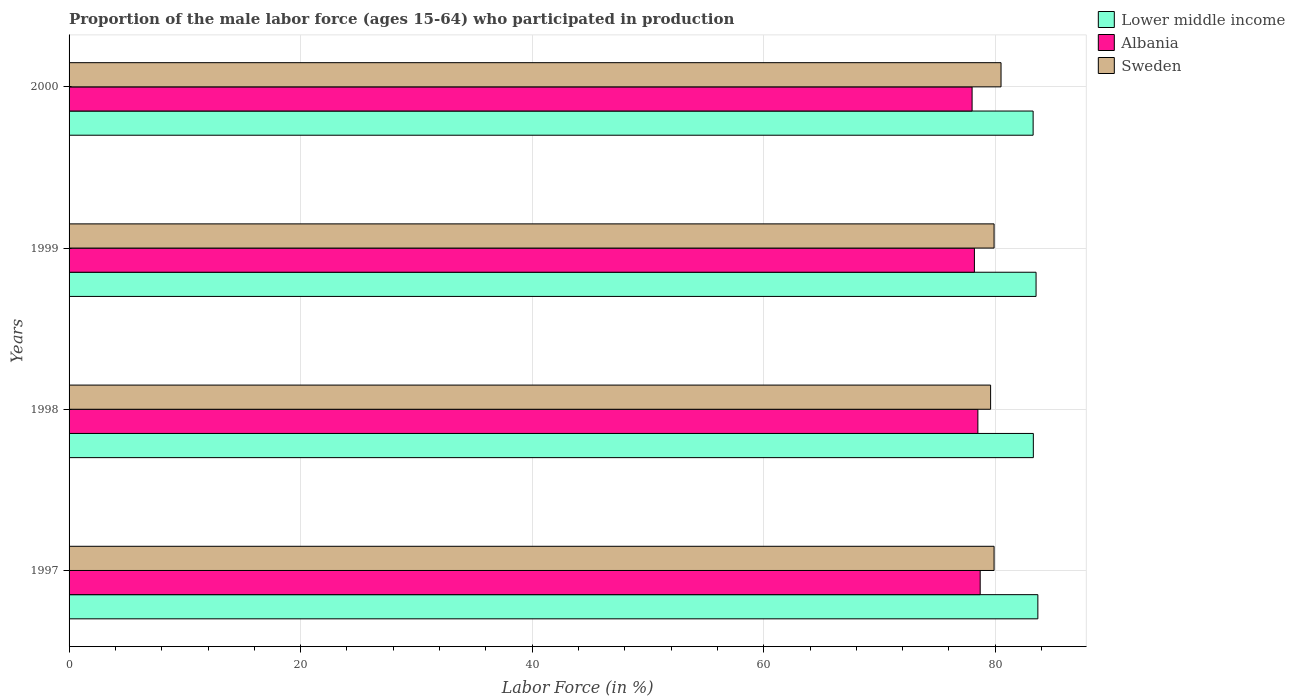Are the number of bars on each tick of the Y-axis equal?
Keep it short and to the point. Yes. How many bars are there on the 2nd tick from the bottom?
Provide a short and direct response. 3. What is the proportion of the male labor force who participated in production in Sweden in 1999?
Keep it short and to the point. 79.9. Across all years, what is the maximum proportion of the male labor force who participated in production in Sweden?
Your response must be concise. 80.5. Across all years, what is the minimum proportion of the male labor force who participated in production in Sweden?
Your response must be concise. 79.6. In which year was the proportion of the male labor force who participated in production in Albania maximum?
Offer a very short reply. 1997. In which year was the proportion of the male labor force who participated in production in Lower middle income minimum?
Offer a terse response. 2000. What is the total proportion of the male labor force who participated in production in Albania in the graph?
Make the answer very short. 313.4. What is the difference between the proportion of the male labor force who participated in production in Lower middle income in 1997 and that in 1998?
Give a very brief answer. 0.39. What is the difference between the proportion of the male labor force who participated in production in Albania in 2000 and the proportion of the male labor force who participated in production in Lower middle income in 1998?
Provide a short and direct response. -5.29. What is the average proportion of the male labor force who participated in production in Sweden per year?
Keep it short and to the point. 79.98. In how many years, is the proportion of the male labor force who participated in production in Lower middle income greater than 4 %?
Your answer should be very brief. 4. What is the ratio of the proportion of the male labor force who participated in production in Sweden in 1999 to that in 2000?
Your response must be concise. 0.99. Is the proportion of the male labor force who participated in production in Albania in 1998 less than that in 1999?
Your answer should be very brief. No. What is the difference between the highest and the second highest proportion of the male labor force who participated in production in Sweden?
Make the answer very short. 0.6. What is the difference between the highest and the lowest proportion of the male labor force who participated in production in Albania?
Your response must be concise. 0.7. In how many years, is the proportion of the male labor force who participated in production in Albania greater than the average proportion of the male labor force who participated in production in Albania taken over all years?
Ensure brevity in your answer.  2. How many bars are there?
Your answer should be compact. 12. Are all the bars in the graph horizontal?
Provide a short and direct response. Yes. What is the difference between two consecutive major ticks on the X-axis?
Provide a short and direct response. 20. Are the values on the major ticks of X-axis written in scientific E-notation?
Provide a short and direct response. No. Does the graph contain grids?
Make the answer very short. Yes. How many legend labels are there?
Your answer should be compact. 3. How are the legend labels stacked?
Your answer should be compact. Vertical. What is the title of the graph?
Offer a terse response. Proportion of the male labor force (ages 15-64) who participated in production. Does "Macedonia" appear as one of the legend labels in the graph?
Make the answer very short. No. What is the label or title of the X-axis?
Your answer should be compact. Labor Force (in %). What is the Labor Force (in %) of Lower middle income in 1997?
Offer a terse response. 83.68. What is the Labor Force (in %) of Albania in 1997?
Offer a very short reply. 78.7. What is the Labor Force (in %) in Sweden in 1997?
Give a very brief answer. 79.9. What is the Labor Force (in %) in Lower middle income in 1998?
Provide a short and direct response. 83.29. What is the Labor Force (in %) in Albania in 1998?
Give a very brief answer. 78.5. What is the Labor Force (in %) in Sweden in 1998?
Provide a short and direct response. 79.6. What is the Labor Force (in %) in Lower middle income in 1999?
Your response must be concise. 83.53. What is the Labor Force (in %) of Albania in 1999?
Offer a very short reply. 78.2. What is the Labor Force (in %) in Sweden in 1999?
Your answer should be compact. 79.9. What is the Labor Force (in %) of Lower middle income in 2000?
Ensure brevity in your answer.  83.27. What is the Labor Force (in %) of Albania in 2000?
Ensure brevity in your answer.  78. What is the Labor Force (in %) of Sweden in 2000?
Keep it short and to the point. 80.5. Across all years, what is the maximum Labor Force (in %) of Lower middle income?
Make the answer very short. 83.68. Across all years, what is the maximum Labor Force (in %) of Albania?
Provide a succinct answer. 78.7. Across all years, what is the maximum Labor Force (in %) of Sweden?
Make the answer very short. 80.5. Across all years, what is the minimum Labor Force (in %) of Lower middle income?
Provide a short and direct response. 83.27. Across all years, what is the minimum Labor Force (in %) of Albania?
Offer a very short reply. 78. Across all years, what is the minimum Labor Force (in %) in Sweden?
Ensure brevity in your answer.  79.6. What is the total Labor Force (in %) of Lower middle income in the graph?
Your response must be concise. 333.77. What is the total Labor Force (in %) of Albania in the graph?
Keep it short and to the point. 313.4. What is the total Labor Force (in %) of Sweden in the graph?
Offer a terse response. 319.9. What is the difference between the Labor Force (in %) in Lower middle income in 1997 and that in 1998?
Make the answer very short. 0.39. What is the difference between the Labor Force (in %) in Sweden in 1997 and that in 1998?
Give a very brief answer. 0.3. What is the difference between the Labor Force (in %) in Lower middle income in 1997 and that in 1999?
Make the answer very short. 0.16. What is the difference between the Labor Force (in %) in Lower middle income in 1997 and that in 2000?
Provide a short and direct response. 0.41. What is the difference between the Labor Force (in %) of Sweden in 1997 and that in 2000?
Your answer should be compact. -0.6. What is the difference between the Labor Force (in %) in Lower middle income in 1998 and that in 1999?
Give a very brief answer. -0.23. What is the difference between the Labor Force (in %) of Albania in 1998 and that in 1999?
Your response must be concise. 0.3. What is the difference between the Labor Force (in %) in Lower middle income in 1998 and that in 2000?
Your answer should be compact. 0.02. What is the difference between the Labor Force (in %) in Sweden in 1998 and that in 2000?
Your response must be concise. -0.9. What is the difference between the Labor Force (in %) in Lower middle income in 1999 and that in 2000?
Give a very brief answer. 0.25. What is the difference between the Labor Force (in %) of Albania in 1999 and that in 2000?
Provide a succinct answer. 0.2. What is the difference between the Labor Force (in %) of Sweden in 1999 and that in 2000?
Offer a very short reply. -0.6. What is the difference between the Labor Force (in %) of Lower middle income in 1997 and the Labor Force (in %) of Albania in 1998?
Keep it short and to the point. 5.18. What is the difference between the Labor Force (in %) in Lower middle income in 1997 and the Labor Force (in %) in Sweden in 1998?
Offer a very short reply. 4.08. What is the difference between the Labor Force (in %) of Lower middle income in 1997 and the Labor Force (in %) of Albania in 1999?
Offer a terse response. 5.48. What is the difference between the Labor Force (in %) of Lower middle income in 1997 and the Labor Force (in %) of Sweden in 1999?
Your answer should be compact. 3.78. What is the difference between the Labor Force (in %) in Lower middle income in 1997 and the Labor Force (in %) in Albania in 2000?
Provide a succinct answer. 5.68. What is the difference between the Labor Force (in %) of Lower middle income in 1997 and the Labor Force (in %) of Sweden in 2000?
Your answer should be very brief. 3.18. What is the difference between the Labor Force (in %) in Albania in 1997 and the Labor Force (in %) in Sweden in 2000?
Give a very brief answer. -1.8. What is the difference between the Labor Force (in %) of Lower middle income in 1998 and the Labor Force (in %) of Albania in 1999?
Give a very brief answer. 5.09. What is the difference between the Labor Force (in %) of Lower middle income in 1998 and the Labor Force (in %) of Sweden in 1999?
Provide a succinct answer. 3.39. What is the difference between the Labor Force (in %) of Albania in 1998 and the Labor Force (in %) of Sweden in 1999?
Provide a succinct answer. -1.4. What is the difference between the Labor Force (in %) of Lower middle income in 1998 and the Labor Force (in %) of Albania in 2000?
Provide a short and direct response. 5.29. What is the difference between the Labor Force (in %) of Lower middle income in 1998 and the Labor Force (in %) of Sweden in 2000?
Provide a succinct answer. 2.79. What is the difference between the Labor Force (in %) in Albania in 1998 and the Labor Force (in %) in Sweden in 2000?
Your answer should be compact. -2. What is the difference between the Labor Force (in %) in Lower middle income in 1999 and the Labor Force (in %) in Albania in 2000?
Your response must be concise. 5.53. What is the difference between the Labor Force (in %) of Lower middle income in 1999 and the Labor Force (in %) of Sweden in 2000?
Provide a short and direct response. 3.03. What is the average Labor Force (in %) in Lower middle income per year?
Make the answer very short. 83.44. What is the average Labor Force (in %) in Albania per year?
Provide a short and direct response. 78.35. What is the average Labor Force (in %) of Sweden per year?
Keep it short and to the point. 79.97. In the year 1997, what is the difference between the Labor Force (in %) of Lower middle income and Labor Force (in %) of Albania?
Your response must be concise. 4.98. In the year 1997, what is the difference between the Labor Force (in %) in Lower middle income and Labor Force (in %) in Sweden?
Your response must be concise. 3.78. In the year 1998, what is the difference between the Labor Force (in %) in Lower middle income and Labor Force (in %) in Albania?
Offer a very short reply. 4.79. In the year 1998, what is the difference between the Labor Force (in %) of Lower middle income and Labor Force (in %) of Sweden?
Offer a very short reply. 3.69. In the year 1999, what is the difference between the Labor Force (in %) in Lower middle income and Labor Force (in %) in Albania?
Give a very brief answer. 5.33. In the year 1999, what is the difference between the Labor Force (in %) of Lower middle income and Labor Force (in %) of Sweden?
Your answer should be very brief. 3.63. In the year 1999, what is the difference between the Labor Force (in %) in Albania and Labor Force (in %) in Sweden?
Provide a succinct answer. -1.7. In the year 2000, what is the difference between the Labor Force (in %) in Lower middle income and Labor Force (in %) in Albania?
Give a very brief answer. 5.27. In the year 2000, what is the difference between the Labor Force (in %) in Lower middle income and Labor Force (in %) in Sweden?
Ensure brevity in your answer.  2.77. What is the ratio of the Labor Force (in %) in Lower middle income in 1997 to that in 1998?
Provide a short and direct response. 1. What is the ratio of the Labor Force (in %) in Sweden in 1997 to that in 1998?
Your answer should be compact. 1. What is the ratio of the Labor Force (in %) of Lower middle income in 1997 to that in 1999?
Ensure brevity in your answer.  1. What is the ratio of the Labor Force (in %) of Albania in 1997 to that in 1999?
Your answer should be compact. 1.01. What is the ratio of the Labor Force (in %) of Lower middle income in 1997 to that in 2000?
Your answer should be compact. 1. What is the ratio of the Labor Force (in %) of Albania in 1997 to that in 2000?
Provide a short and direct response. 1.01. What is the ratio of the Labor Force (in %) in Sweden in 1997 to that in 2000?
Your response must be concise. 0.99. What is the ratio of the Labor Force (in %) of Lower middle income in 1998 to that in 1999?
Offer a terse response. 1. What is the ratio of the Labor Force (in %) in Sweden in 1998 to that in 1999?
Provide a succinct answer. 1. What is the ratio of the Labor Force (in %) of Albania in 1998 to that in 2000?
Your response must be concise. 1.01. What is the ratio of the Labor Force (in %) of Sweden in 1998 to that in 2000?
Keep it short and to the point. 0.99. What is the ratio of the Labor Force (in %) of Lower middle income in 1999 to that in 2000?
Ensure brevity in your answer.  1. What is the difference between the highest and the second highest Labor Force (in %) in Lower middle income?
Your answer should be very brief. 0.16. What is the difference between the highest and the second highest Labor Force (in %) in Albania?
Ensure brevity in your answer.  0.2. What is the difference between the highest and the lowest Labor Force (in %) of Lower middle income?
Offer a terse response. 0.41. What is the difference between the highest and the lowest Labor Force (in %) in Albania?
Your answer should be very brief. 0.7. What is the difference between the highest and the lowest Labor Force (in %) in Sweden?
Give a very brief answer. 0.9. 